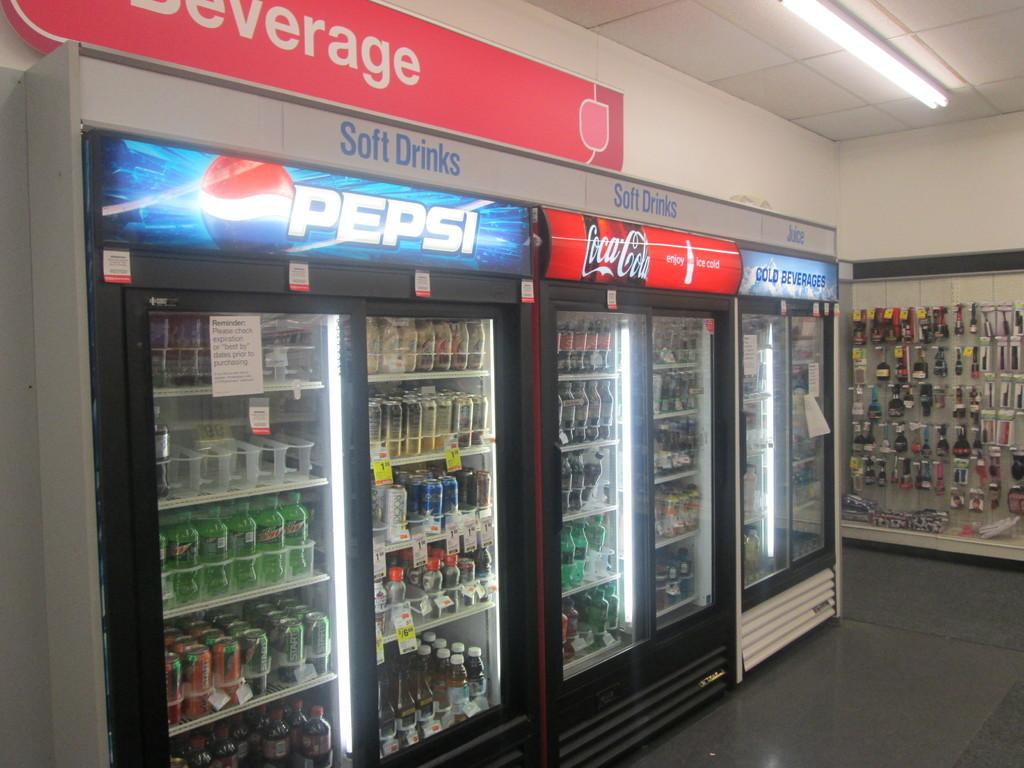<image>
Share a concise interpretation of the image provided. a fridge with the word Pepsi at the top of one 